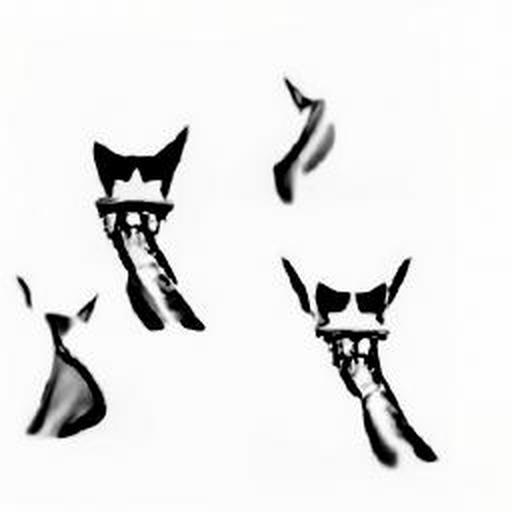What emotions does the image seem to evoke? The image appears to evoke a sense of movement and fluidity due to the blurry lines and forms, which could lead viewers to experience feelings of curiosity and intrigue. The ephemeral quality of the subjects may also elicit a reflective or dream-like emotional response. 